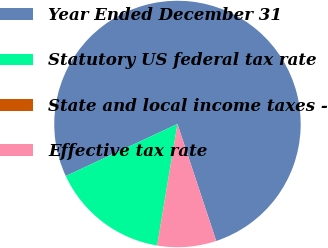Convert chart to OTSL. <chart><loc_0><loc_0><loc_500><loc_500><pie_chart><fcel>Year Ended December 31<fcel>Statutory US federal tax rate<fcel>State and local income taxes -<fcel>Effective tax rate<nl><fcel>76.85%<fcel>15.4%<fcel>0.03%<fcel>7.72%<nl></chart> 